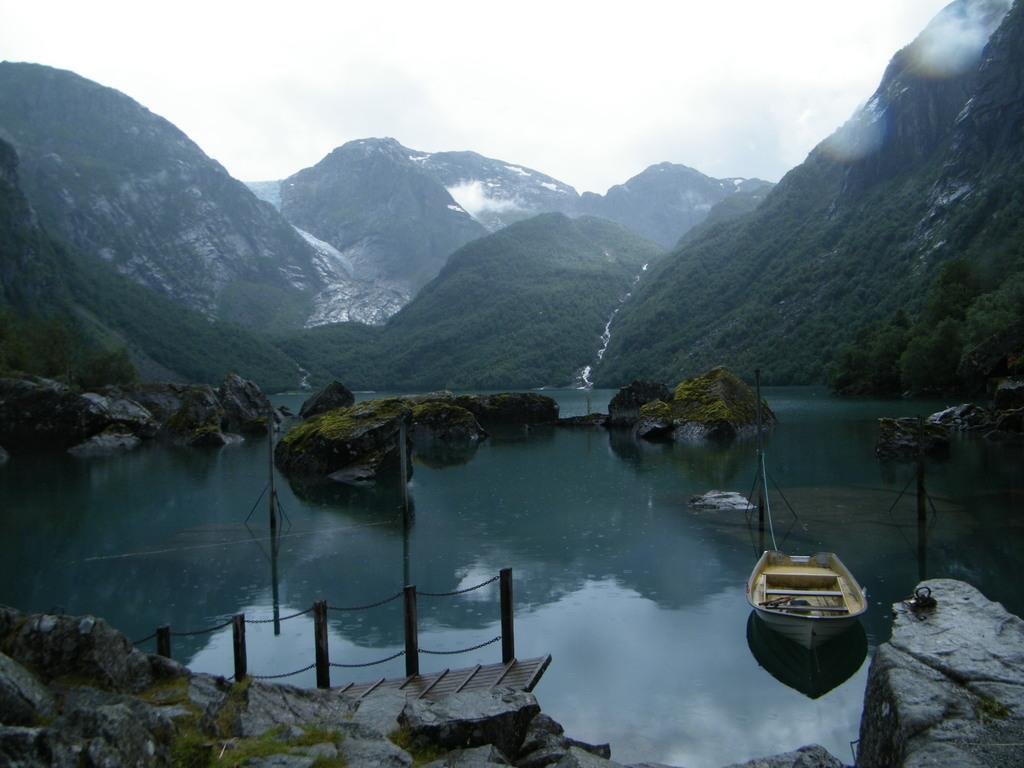What is the main subject of the image? The main subject of the image is a boat. Where is the boat located? The boat is on the water. What can be seen near the boat? There are rocks beside the boat. What other structures are present in the image? There is a small bridge in the image. What type of natural scenery is visible in the background? There are trees and hills in the background of the image. How many tomatoes are being carried by the self in the image? There is no self or tomatoes present in the image. What type of motion is the boat exhibiting in the image? The boat is not exhibiting any motion in the image; it appears to be stationary on the water. 